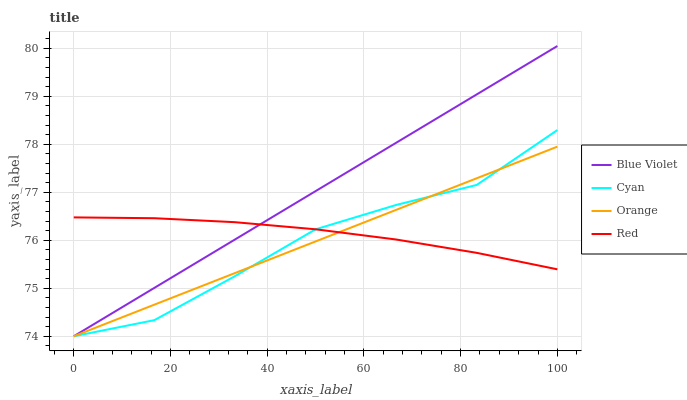Does Orange have the minimum area under the curve?
Answer yes or no. Yes. Does Blue Violet have the maximum area under the curve?
Answer yes or no. Yes. Does Cyan have the minimum area under the curve?
Answer yes or no. No. Does Cyan have the maximum area under the curve?
Answer yes or no. No. Is Blue Violet the smoothest?
Answer yes or no. Yes. Is Cyan the roughest?
Answer yes or no. Yes. Is Red the smoothest?
Answer yes or no. No. Is Red the roughest?
Answer yes or no. No. Does Orange have the lowest value?
Answer yes or no. Yes. Does Red have the lowest value?
Answer yes or no. No. Does Blue Violet have the highest value?
Answer yes or no. Yes. Does Cyan have the highest value?
Answer yes or no. No. Does Blue Violet intersect Orange?
Answer yes or no. Yes. Is Blue Violet less than Orange?
Answer yes or no. No. Is Blue Violet greater than Orange?
Answer yes or no. No. 